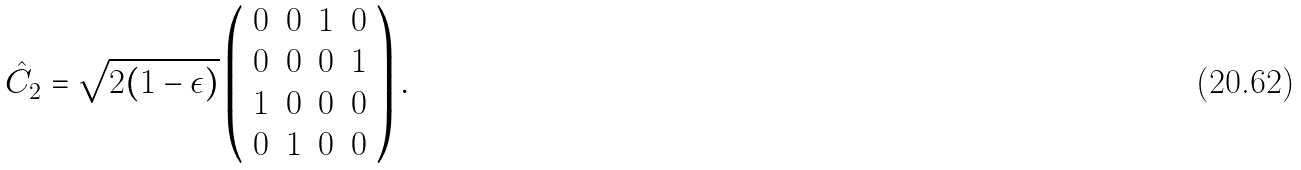Convert formula to latex. <formula><loc_0><loc_0><loc_500><loc_500>\hat { C } _ { 2 } = \sqrt { 2 ( 1 - \epsilon ) } \left ( \begin{array} { c c c c } 0 & 0 & 1 & 0 \\ 0 & 0 & 0 & 1 \\ 1 & 0 & 0 & 0 \\ 0 & 1 & 0 & 0 \\ \end{array} \right ) .</formula> 